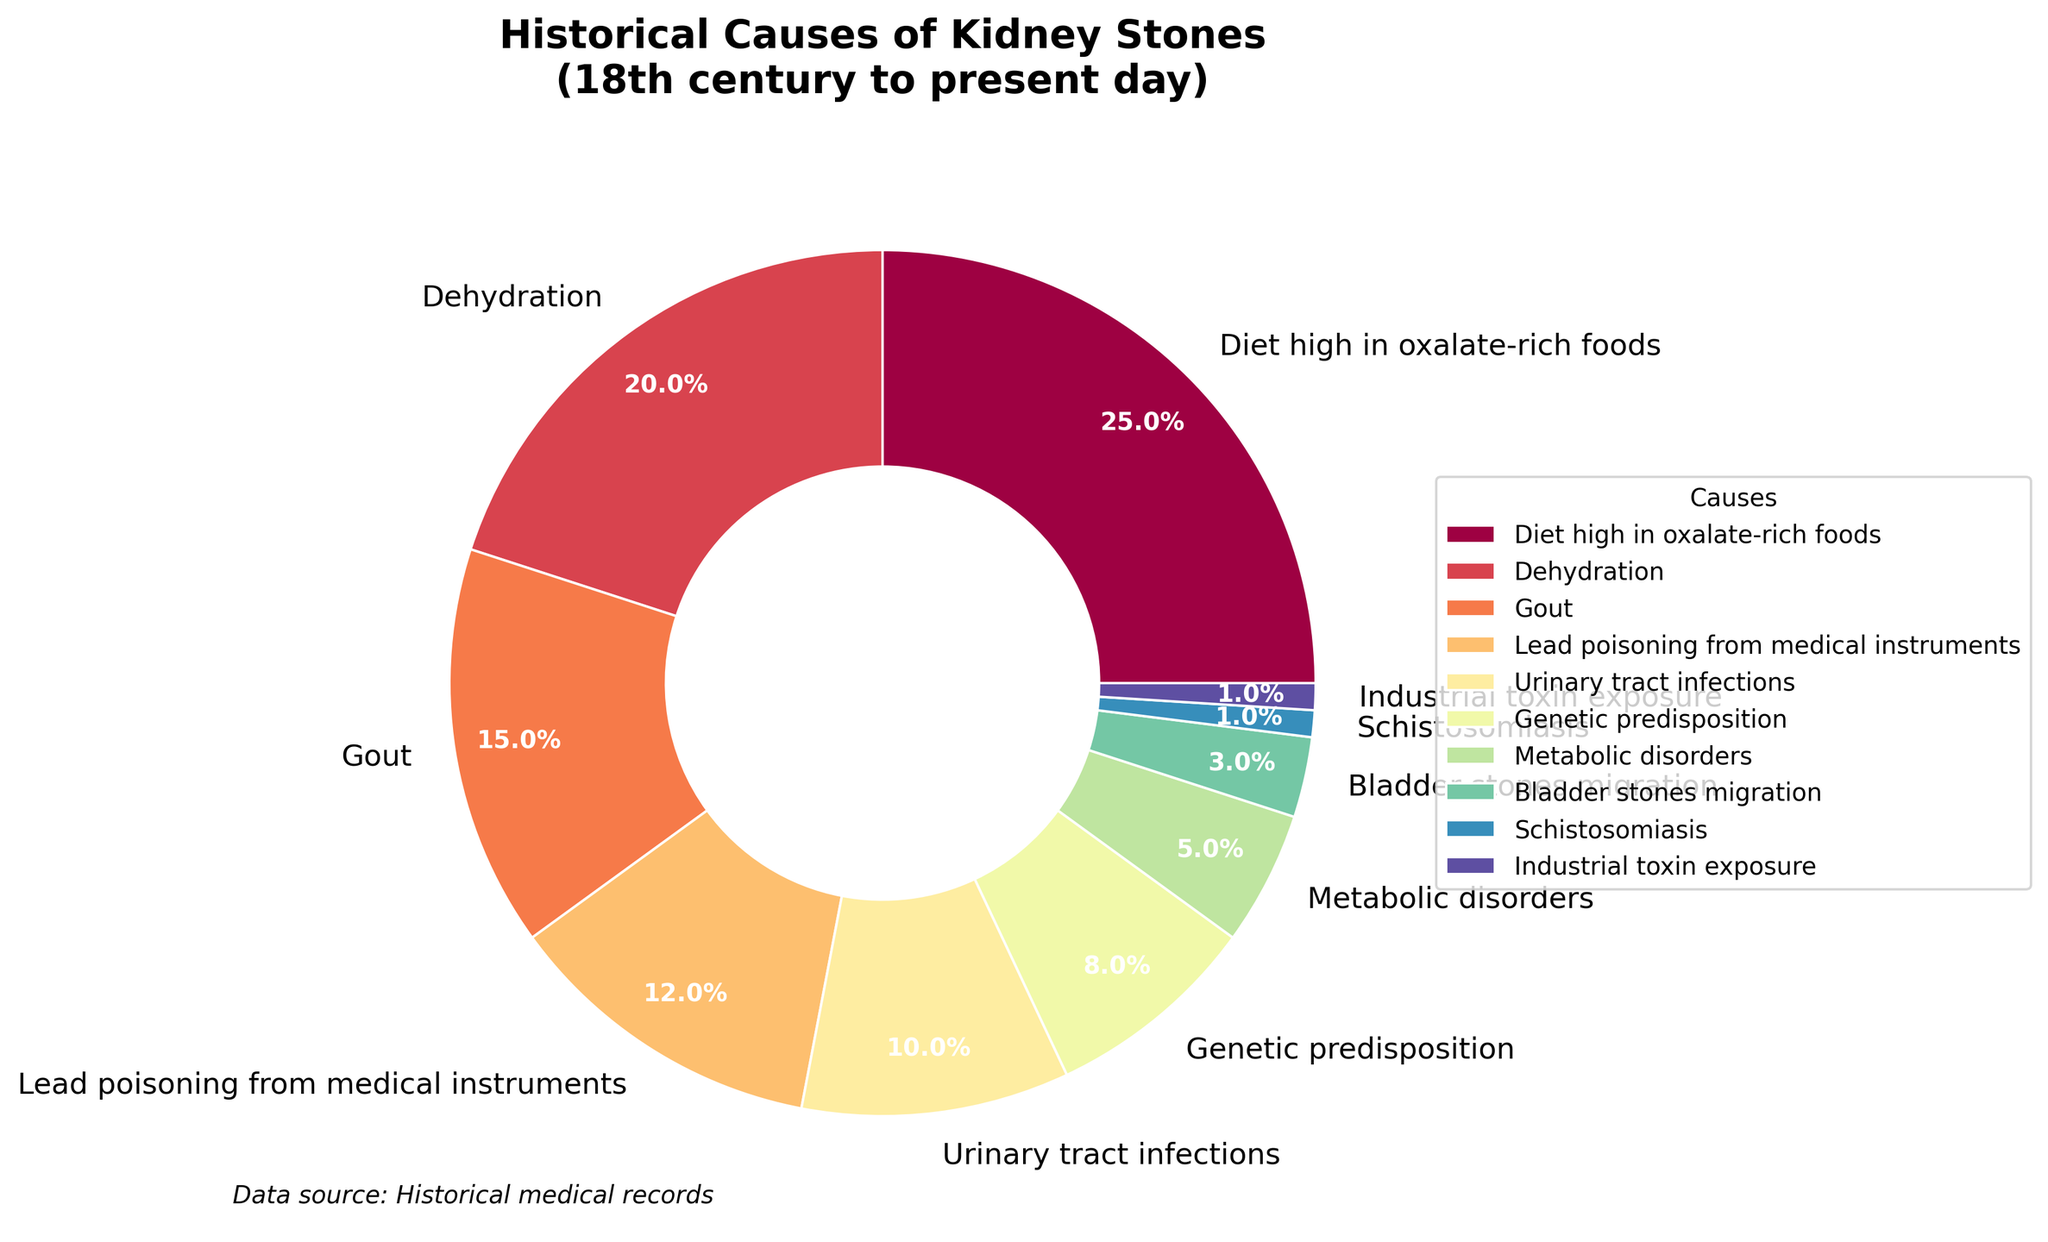What are the two leading historical causes of kidney stones? The pie chart indicates the percentage breakdown of various causes of kidney stones. By examining the chart, it's clear that "Diet high in oxalate-rich foods" and "Dehydration" have the highest percentages of 25% and 20% respectively.
Answer: Diet high in oxalate-rich foods and Dehydration What percentage of historical kidney stones are attributed to genetic predisposition and metabolic disorders combined? Summing the percentages for "Genetic predisposition" and "Metabolic disorders" gives 8% + 5% = 13%.
Answer: 13% Is urinary tract infections a more common cause of kidney stones than lead poisoning from medical instruments? Yes, "Urinary tract infections" account for 10%, while "Lead poisoning from medical instruments" account for 12% as shown in the pie chart
Answer: No Which less common cause of kidney stones has the smallest percentage share? From the pie chart, "Schistosomiasis" and "Industrial toxin exposure" both have the smallest percentage of 1% each.
Answer: Schistosomiasis and Industrial toxin exposure How much greater is the percentage of kidney stones caused by gout compared to bladder stones migration? Subtract the percentage of "Bladder stones migration" (3%) from "Gout" (15%): 15% - 3% = 12%.
Answer: 12% What cause is represented by the second lightest shade on the pie chart? According to the pie chart's color gradient in the spectral color map, the second lightest shade represents "Industrial toxin exposure" with 1%.
Answer: Industrial toxin exposure List the causes of kidney stones that have a percentage of 10% or higher. The pie chart shows causes with these percentages: "Diet high in oxalate-rich foods" (25%), "Dehydration" (20%), "Gout" (15%), and "Lead poisoning from medical instruments" (12%).
Answer: Diet high in oxalate-rich foods, Dehydration, Gout, Lead poisoning from medical instruments What percentage of historical kidney stones are attributed to causes other than diet high in oxalate-rich foods and dehydration? Summing the remaining causes except "Diet high in oxalate-rich foods" (25%) and "Dehydration" (20%) gives: 100% - (25% + 20%) = 55%.
Answer: 55% 